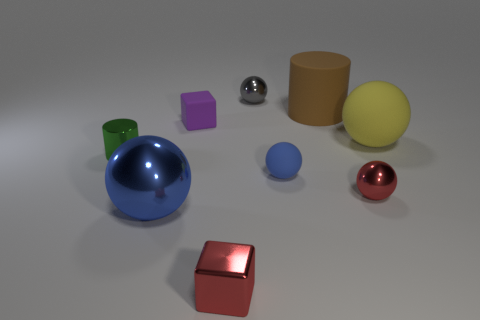What number of things are either blue metallic balls or small purple things?
Offer a terse response. 2. Does the tiny metal sphere behind the big yellow matte object have the same color as the rubber ball to the left of the matte cylinder?
Offer a terse response. No. There is a gray object that is the same size as the metal cylinder; what is its shape?
Your answer should be very brief. Sphere. How many things are either balls on the right side of the large cylinder or small cubes in front of the yellow sphere?
Keep it short and to the point. 3. Are there fewer small gray metal spheres than large blue metal blocks?
Your response must be concise. No. What material is the green cylinder that is the same size as the red sphere?
Make the answer very short. Metal. Do the matte ball to the left of the big yellow ball and the cube that is right of the matte cube have the same size?
Provide a succinct answer. Yes. Is there a purple cube made of the same material as the yellow object?
Give a very brief answer. Yes. How many objects are small red metallic things left of the small gray ball or blue matte cylinders?
Give a very brief answer. 1. Is the material of the cylinder that is behind the large yellow matte object the same as the small green cylinder?
Offer a very short reply. No. 